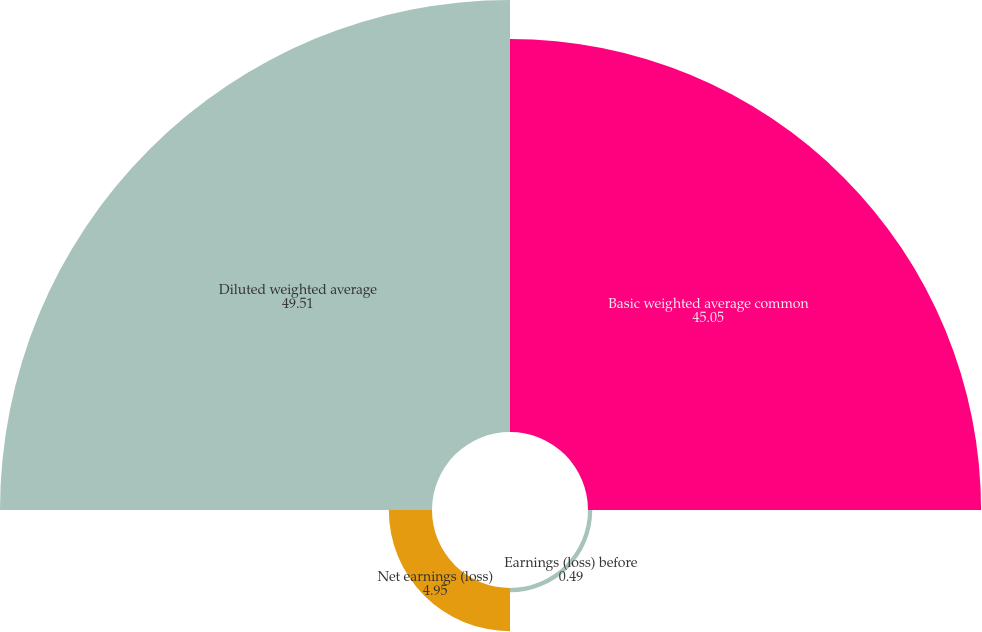Convert chart. <chart><loc_0><loc_0><loc_500><loc_500><pie_chart><fcel>Basic weighted average common<fcel>Earnings (loss) before<fcel>Net earnings (loss)<fcel>Diluted weighted average<nl><fcel>45.05%<fcel>0.49%<fcel>4.95%<fcel>49.51%<nl></chart> 